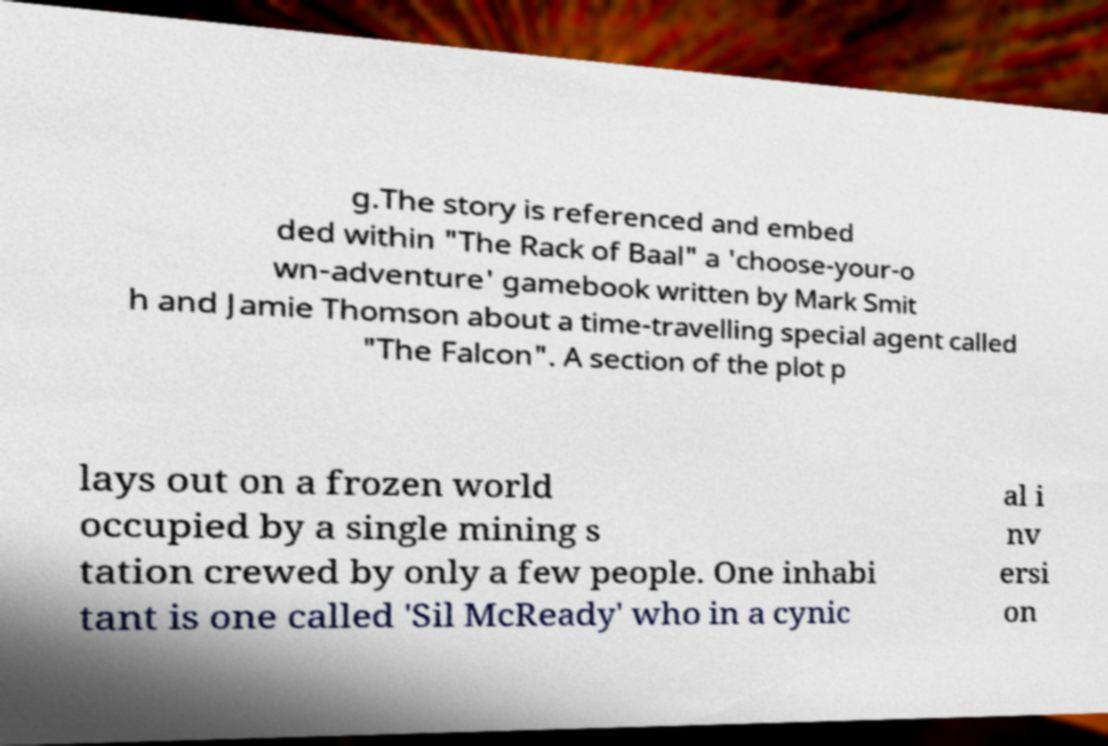There's text embedded in this image that I need extracted. Can you transcribe it verbatim? g.The story is referenced and embed ded within "The Rack of Baal" a 'choose-your-o wn-adventure' gamebook written by Mark Smit h and Jamie Thomson about a time-travelling special agent called "The Falcon". A section of the plot p lays out on a frozen world occupied by a single mining s tation crewed by only a few people. One inhabi tant is one called 'Sil McReady' who in a cynic al i nv ersi on 